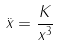<formula> <loc_0><loc_0><loc_500><loc_500>\ddot { x } = \frac { K } { x ^ { 3 } }</formula> 